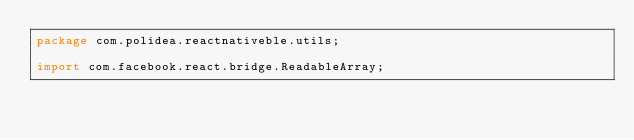<code> <loc_0><loc_0><loc_500><loc_500><_Java_>package com.polidea.reactnativeble.utils;

import com.facebook.react.bridge.ReadableArray;
</code> 